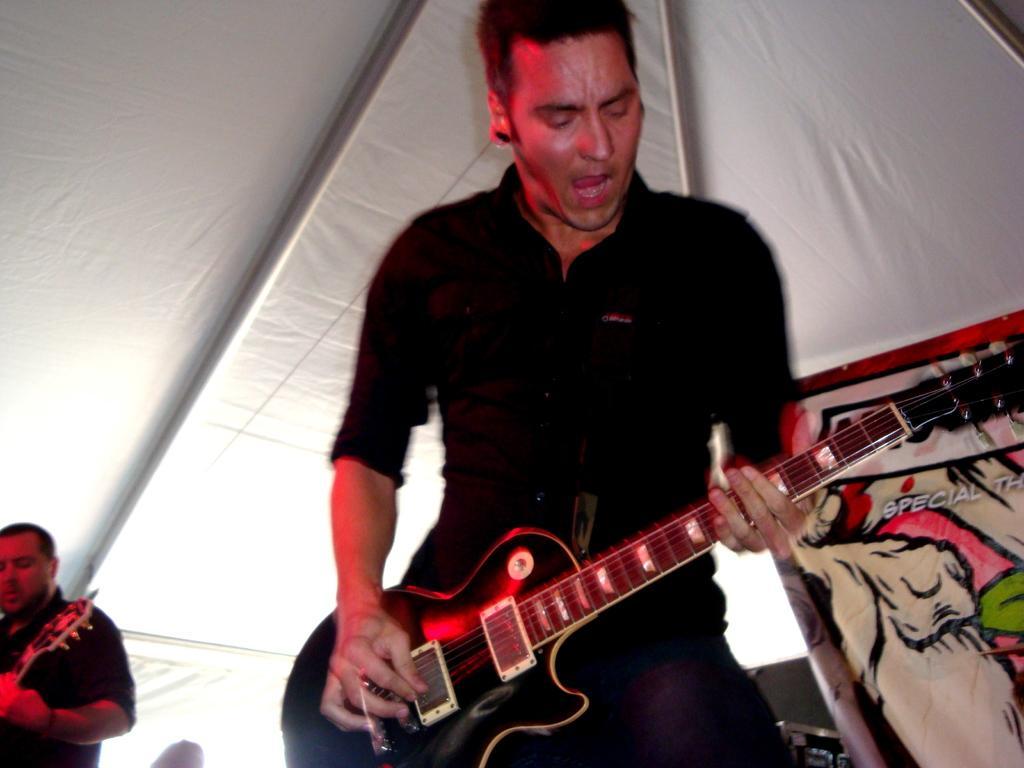In one or two sentences, can you explain what this image depicts? In this image I can see a man wearing black color dress, standing and playing the guitar. It seems like he's also singing a song. On the top of the image I can see a white color tint. On the left corner of the image there is another man holding a guitar in hands. 